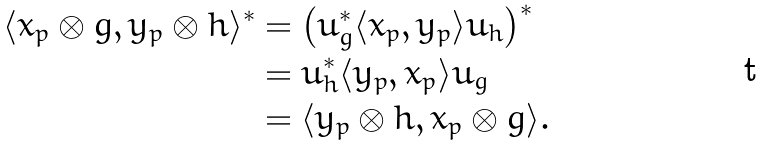<formula> <loc_0><loc_0><loc_500><loc_500>\langle x _ { p } \otimes g , y _ { p } \otimes h \rangle ^ { * } & = \left ( u _ { g } ^ { * } \langle x _ { p } , y _ { p } \rangle u _ { h } \right ) ^ { * } \\ & = u _ { h } ^ { * } \langle y _ { p } , x _ { p } \rangle u _ { g } \\ & = \langle y _ { p } \otimes h , x _ { p } \otimes g \rangle .</formula> 